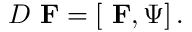Convert formula to latex. <formula><loc_0><loc_0><loc_500><loc_500>D { F } = \left [ { F } , \Psi \right ] .</formula> 